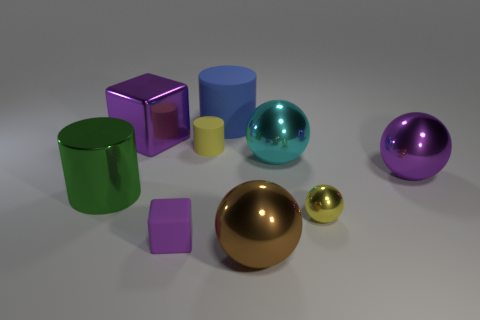What number of other objects are the same size as the purple ball?
Your answer should be compact. 5. There is a purple metal object to the left of the yellow metal ball; is it the same size as the cyan shiny sphere to the right of the big green metal object?
Keep it short and to the point. Yes. What is the size of the purple object that is the same shape as the cyan shiny object?
Your response must be concise. Large. Are there more brown spheres that are in front of the big brown thing than blue rubber objects that are left of the large green cylinder?
Offer a very short reply. No. What is the material of the thing that is both to the left of the small purple object and behind the tiny cylinder?
Provide a succinct answer. Metal. What color is the big rubber thing that is the same shape as the big green metallic object?
Provide a short and direct response. Blue. The blue matte cylinder has what size?
Offer a very short reply. Large. There is a matte object on the left side of the small matte thing behind the large purple metallic ball; what is its color?
Provide a short and direct response. Purple. How many things are both right of the small yellow cylinder and in front of the blue cylinder?
Ensure brevity in your answer.  4. Are there more big gray matte cylinders than purple blocks?
Keep it short and to the point. No. 